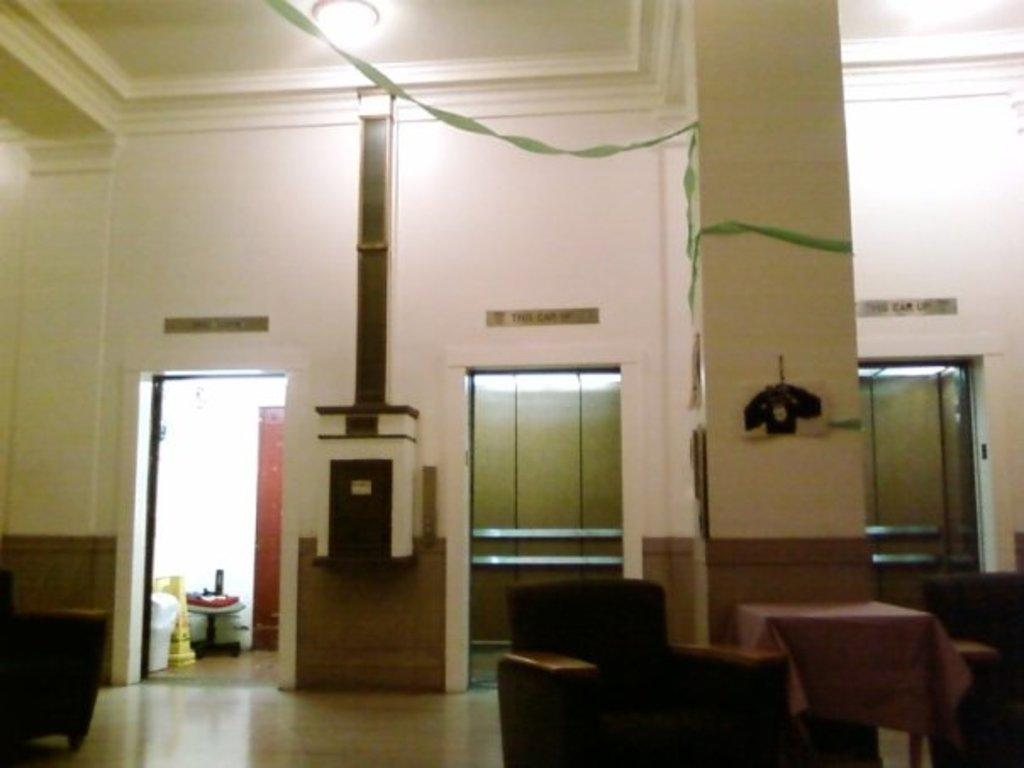What type of structure can be seen in the image? There is a wall and a ceiling in the image. What is used for illumination in the image? There are lights in the image. What architectural features are present in the image? There are pillars in the image. What objects are on the left side of the image? There are objects on the left side of the image, but the specific objects are not mentioned in the facts. What type of furniture is in the image? There are couches and a table in the image. What type of leather is used to make the skate visible in the image? There is no skate present in the image, so it is not possible to determine the type of leather used. 